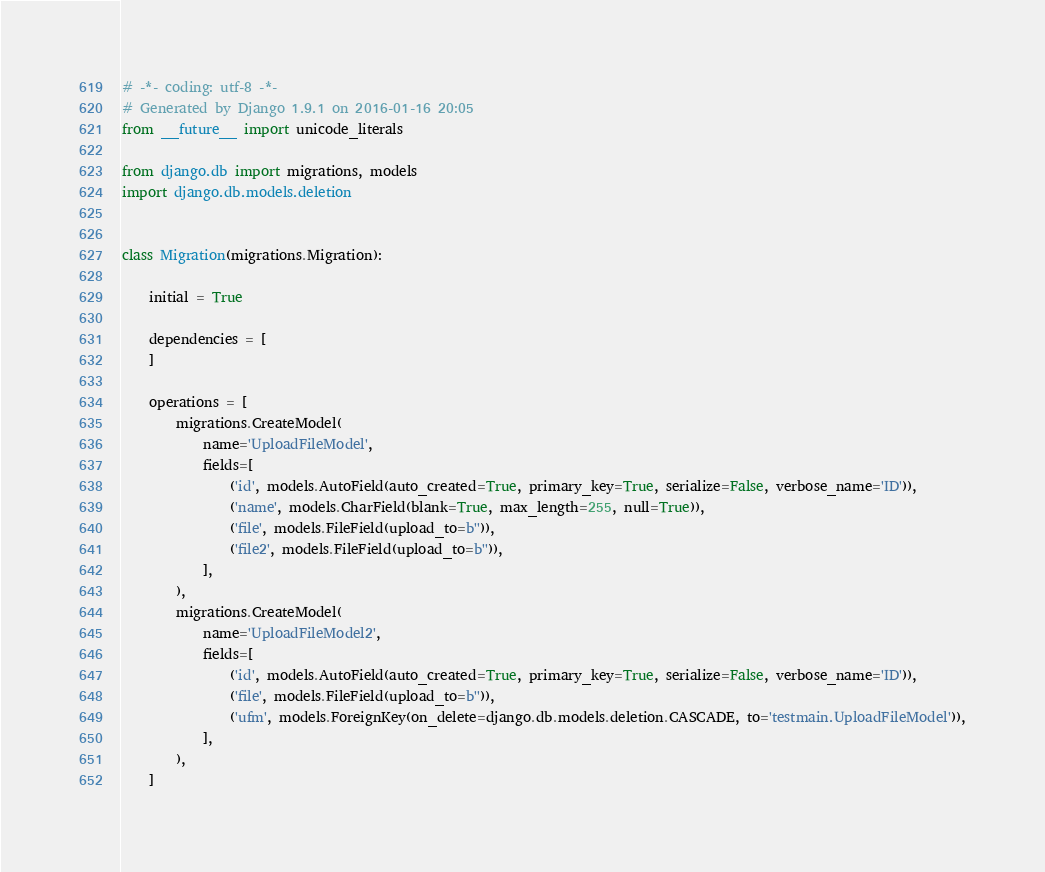Convert code to text. <code><loc_0><loc_0><loc_500><loc_500><_Python_># -*- coding: utf-8 -*-
# Generated by Django 1.9.1 on 2016-01-16 20:05
from __future__ import unicode_literals

from django.db import migrations, models
import django.db.models.deletion


class Migration(migrations.Migration):

    initial = True

    dependencies = [
    ]

    operations = [
        migrations.CreateModel(
            name='UploadFileModel',
            fields=[
                ('id', models.AutoField(auto_created=True, primary_key=True, serialize=False, verbose_name='ID')),
                ('name', models.CharField(blank=True, max_length=255, null=True)),
                ('file', models.FileField(upload_to=b'')),
                ('file2', models.FileField(upload_to=b'')),
            ],
        ),
        migrations.CreateModel(
            name='UploadFileModel2',
            fields=[
                ('id', models.AutoField(auto_created=True, primary_key=True, serialize=False, verbose_name='ID')),
                ('file', models.FileField(upload_to=b'')),
                ('ufm', models.ForeignKey(on_delete=django.db.models.deletion.CASCADE, to='testmain.UploadFileModel')),
            ],
        ),
    ]
</code> 